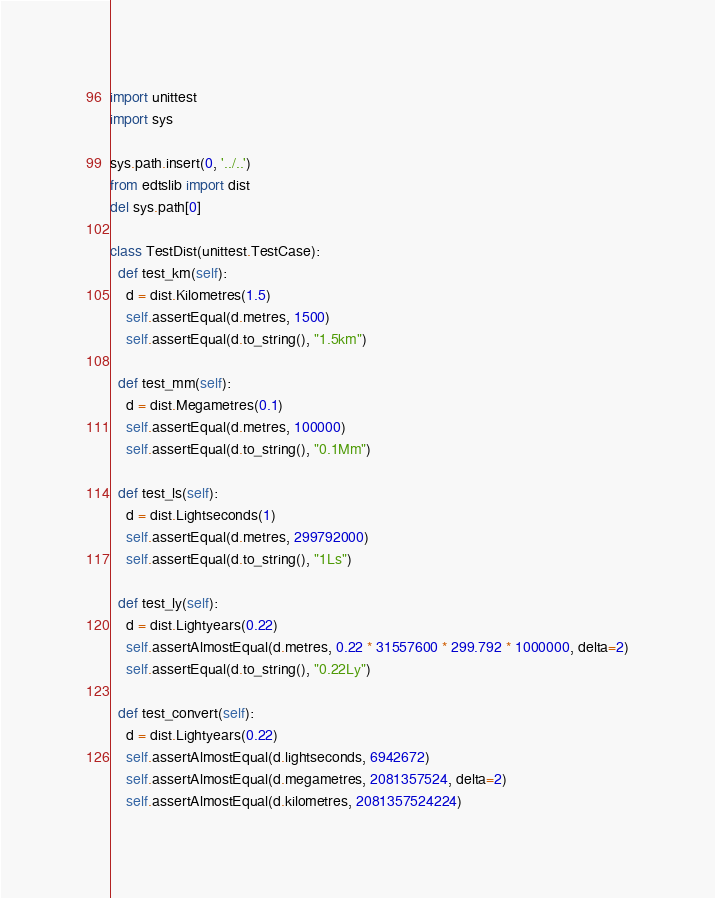Convert code to text. <code><loc_0><loc_0><loc_500><loc_500><_Python_>import unittest
import sys

sys.path.insert(0, '../..')
from edtslib import dist
del sys.path[0]

class TestDist(unittest.TestCase):
  def test_km(self):
    d = dist.Kilometres(1.5)
    self.assertEqual(d.metres, 1500)
    self.assertEqual(d.to_string(), "1.5km")

  def test_mm(self):
    d = dist.Megametres(0.1)
    self.assertEqual(d.metres, 100000)
    self.assertEqual(d.to_string(), "0.1Mm")

  def test_ls(self):
    d = dist.Lightseconds(1)
    self.assertEqual(d.metres, 299792000)
    self.assertEqual(d.to_string(), "1Ls")

  def test_ly(self):
    d = dist.Lightyears(0.22)
    self.assertAlmostEqual(d.metres, 0.22 * 31557600 * 299.792 * 1000000, delta=2)
    self.assertEqual(d.to_string(), "0.22Ly")

  def test_convert(self):
    d = dist.Lightyears(0.22)
    self.assertAlmostEqual(d.lightseconds, 6942672)
    self.assertAlmostEqual(d.megametres, 2081357524, delta=2)
    self.assertAlmostEqual(d.kilometres, 2081357524224)
</code> 